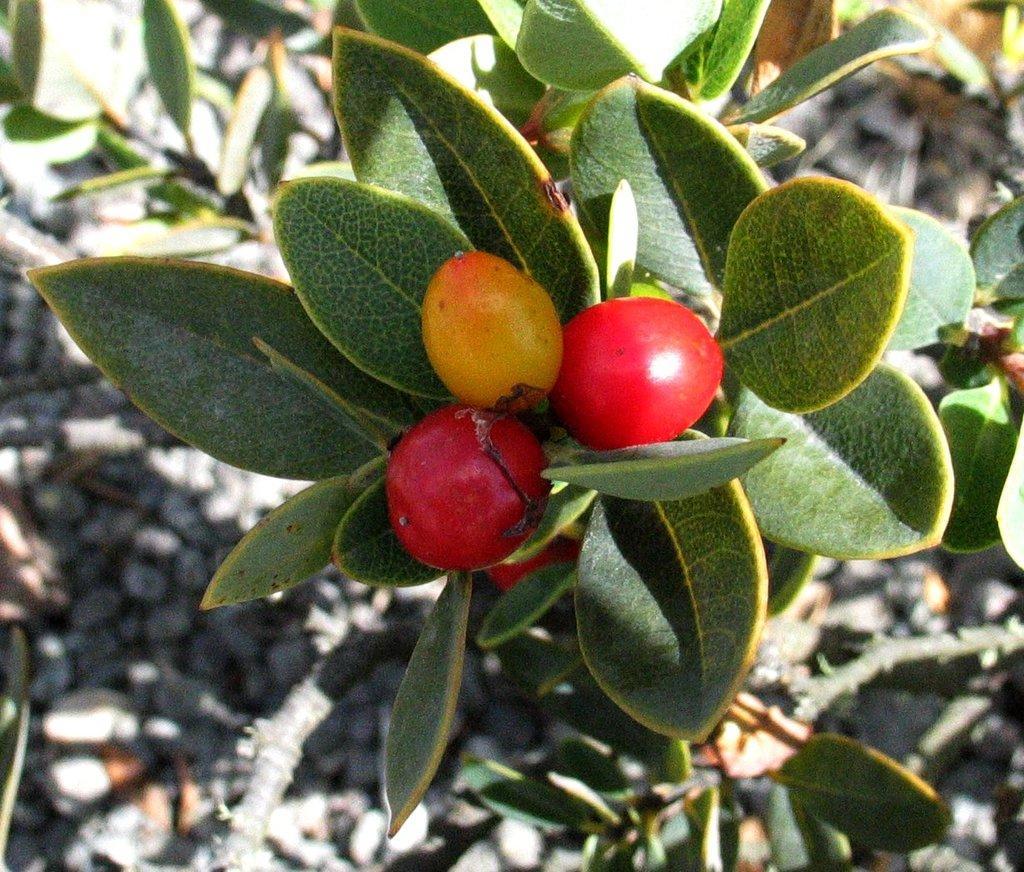Can you describe this image briefly? In the front of the image there are vegetables, leaves and stems. In the background of the image it is blurry.  